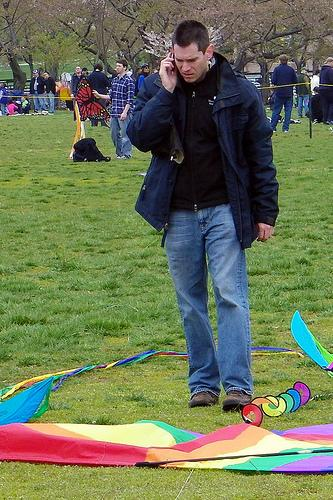Explain the principal entity in the photo and their preoccupation. The main figure in the image, wearing a checkered outfit, is engrossed in a phone call and also holding a kite, amid a park teeming with people and trees. Highlight the central figure and their ongoing task in the scene.  In a park scene filled with people and trees, the key figure is a plaid-clad individual speaking on a cellphone and clutching a kite. Summarize the main character's appearance and activity in the image. It's a picture of a man in a plaid shirt having a phone conversation and holding a kite in a park with trees and a gathering of people. Elaborate on the primary object of interest and their action in the image. The image primarily shows a man in a plaid shirt who is in the middle of a phone call and simultaneously holding a kite, surrounded by trees and people in a park setting. Mention the primary focus of the image and their action. A person wearing checkered shirt talks on his phone, while holding a kite and standing amidst a park with trees and people around. Clarify the image's main subject and the activity they are occupied with. The image is focused on a man, dressed in plaid, engaged in a phone conversation and holding a kite, while surrounded by park scenery with trees and people. Report the center of attention in the picture and their engaging deed. The central attraction here is a man wearing a checkered shirt, talking on his cellphone and holding a kite in a park bustling with trees and people. Specify the focal point of the image and their pursuing accomplishment. A plaid-wearing individual engaged in a phone call while gripping a kite stands out in a park full of people and trees in the image. Identify the prominent element in the picture and their involvement. A person in a checkered shirt holding a kite is the focus, he is talking on phone amidst a park filled with trees and other people. Describe the chief subject of the photo and their engagement. The main subject is a man clad in a checkered shirt, engaged in a phone call and holding a kite while standing in a park with trees and people. 